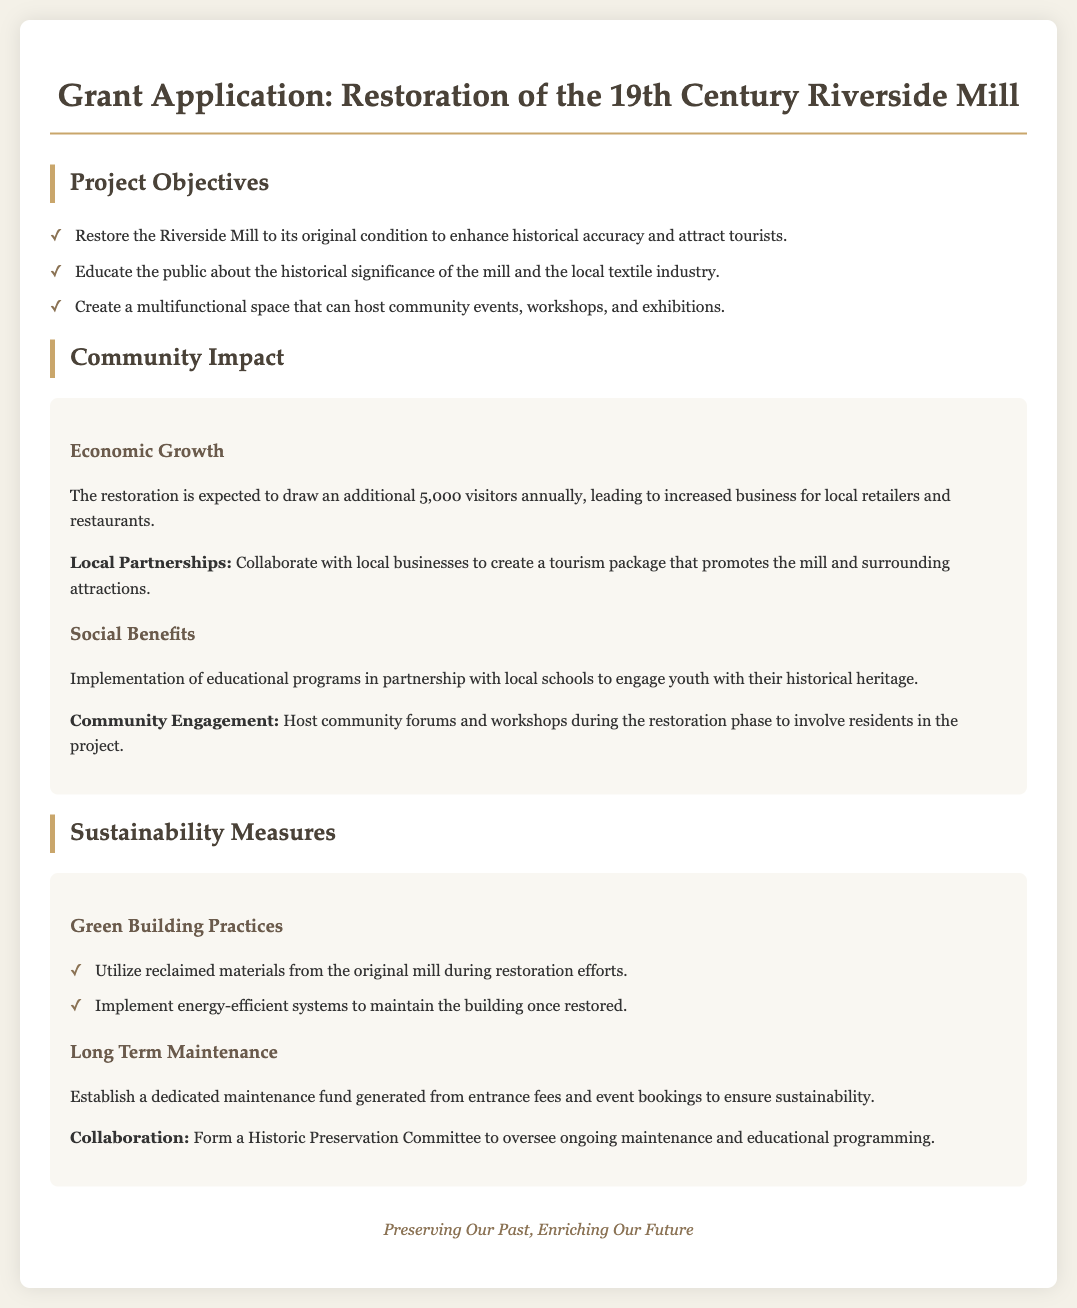What is the project title? The project title is specified at the top of the document, reflecting the main focus of the grant application.
Answer: Restoration of the 19th Century Riverside Mill How many visitors are expected annually? The document states the expected increase in visitors due to the restoration project.
Answer: 5,000 What types of events can the restored mill host? The objectives mention that the restored mill will serve as a multifunctional space, which indicates the variety of community activities it can support.
Answer: Community events, workshops, exhibitions What materials will be used in restoration? The sustainability measures section notes the use of specific materials during the restoration process, highlighting the project's environmental considerations.
Answer: Reclaimed materials Who will oversee ongoing maintenance? The document indicates that a specific committee will be formed for managing maintenance and educational programs related to the mill.
Answer: Historic Preservation Committee What is one goal related to education? The project aims to engage young people and the community with their heritage through specific programs outlined in the objectives.
Answer: Implement educational programs What is a key benefit for local businesses? The economic growth section describes how local businesses will benefit from increased tourism due to the restoration project.
Answer: Increased business What types of practices will be prioritized for sustainability? The sustainability measures provided in the project outline the focus on specific building practices to support sustainable development.
Answer: Green Building Practices 